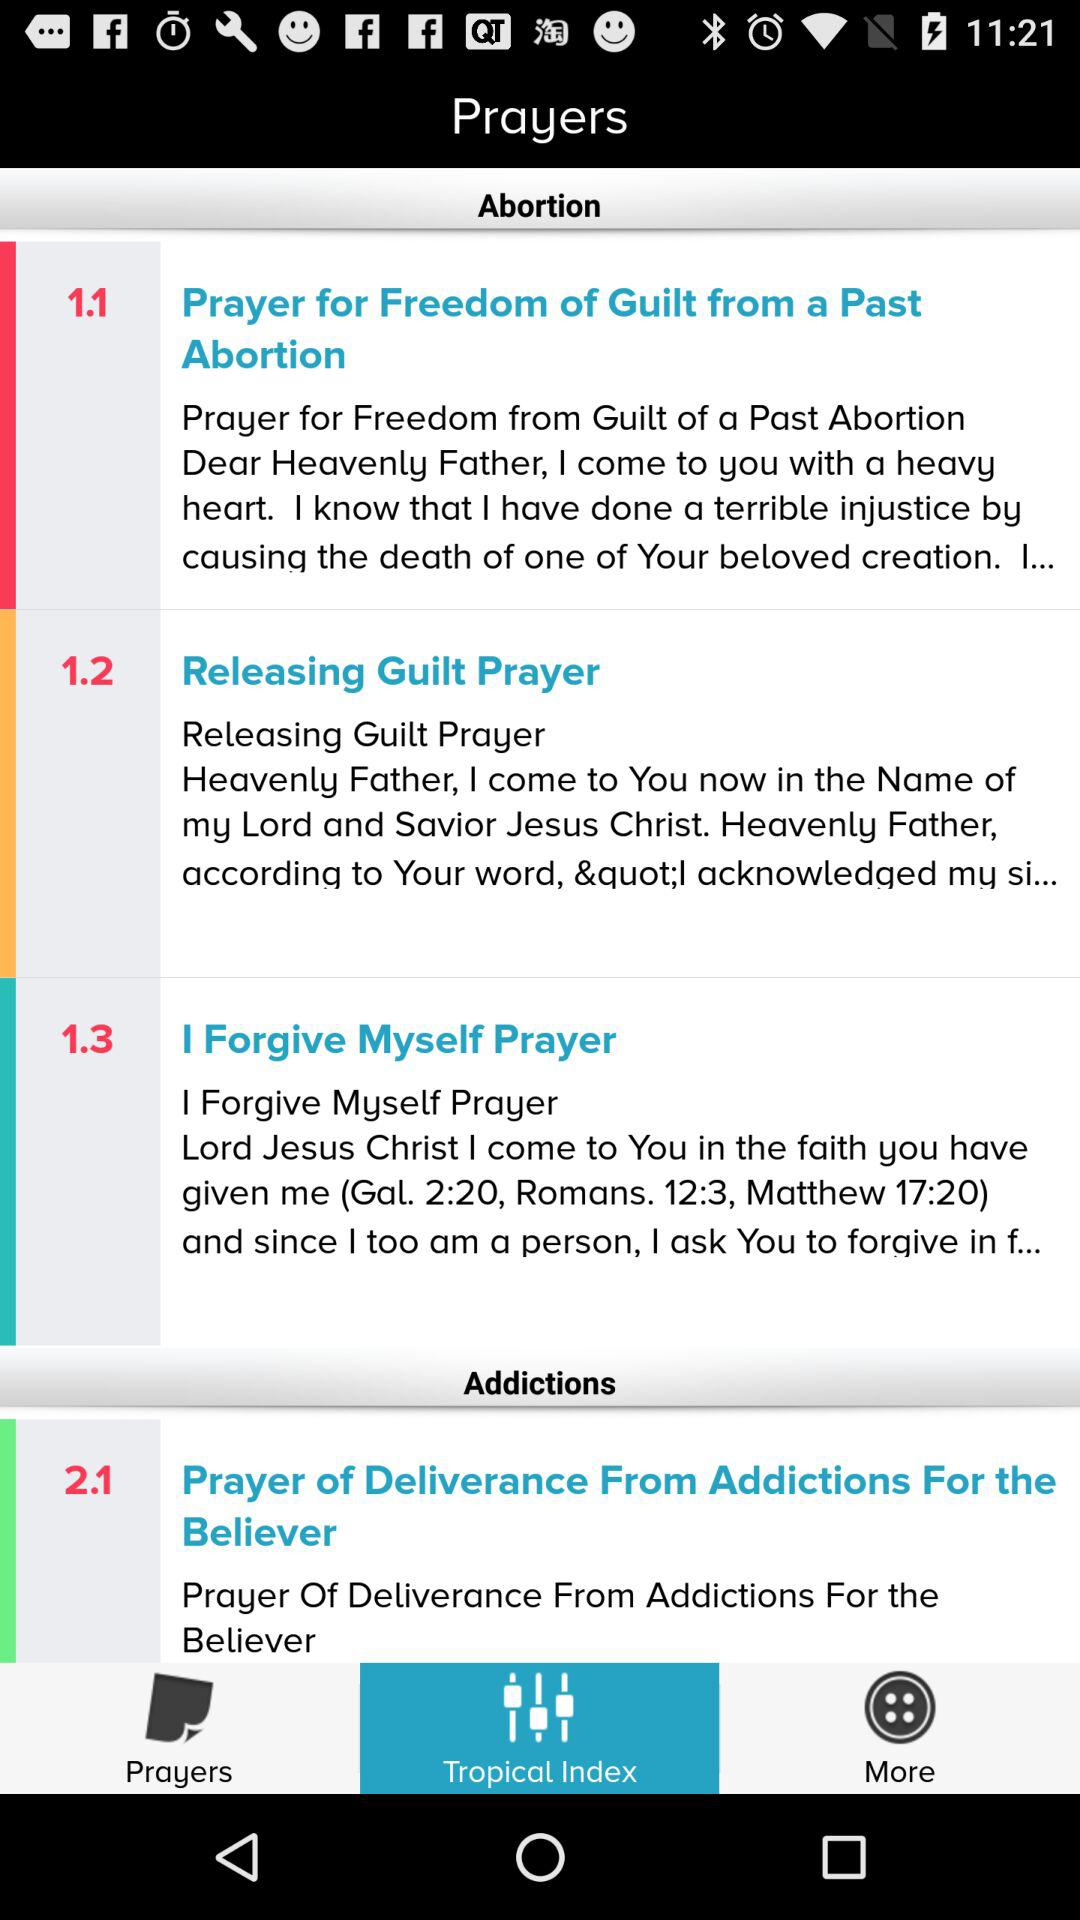How many prayers are there in the 'Addictions' category?
Answer the question using a single word or phrase. 1 